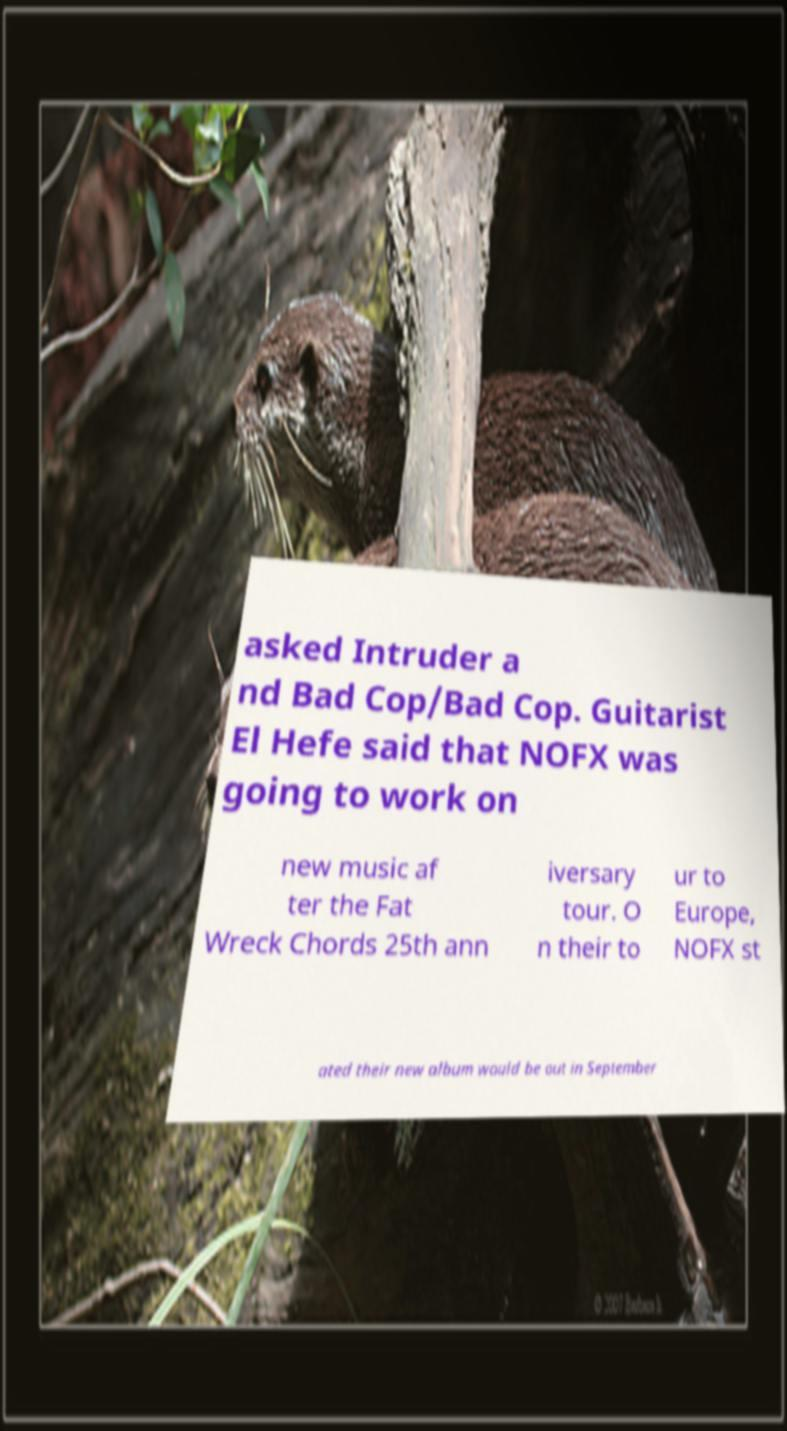Could you extract and type out the text from this image? asked Intruder a nd Bad Cop/Bad Cop. Guitarist El Hefe said that NOFX was going to work on new music af ter the Fat Wreck Chords 25th ann iversary tour. O n their to ur to Europe, NOFX st ated their new album would be out in September 